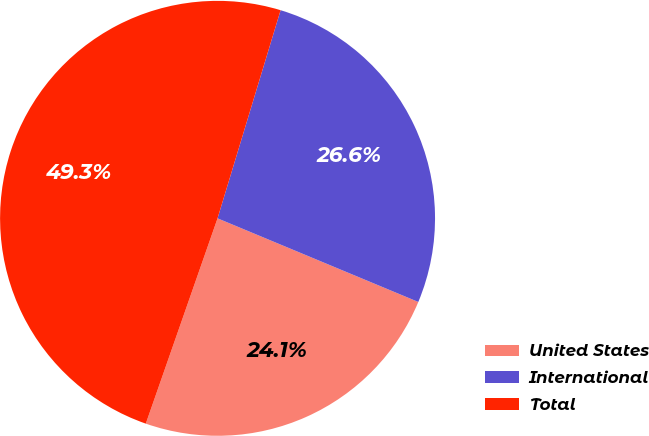<chart> <loc_0><loc_0><loc_500><loc_500><pie_chart><fcel>United States<fcel>International<fcel>Total<nl><fcel>24.07%<fcel>26.6%<fcel>49.33%<nl></chart> 